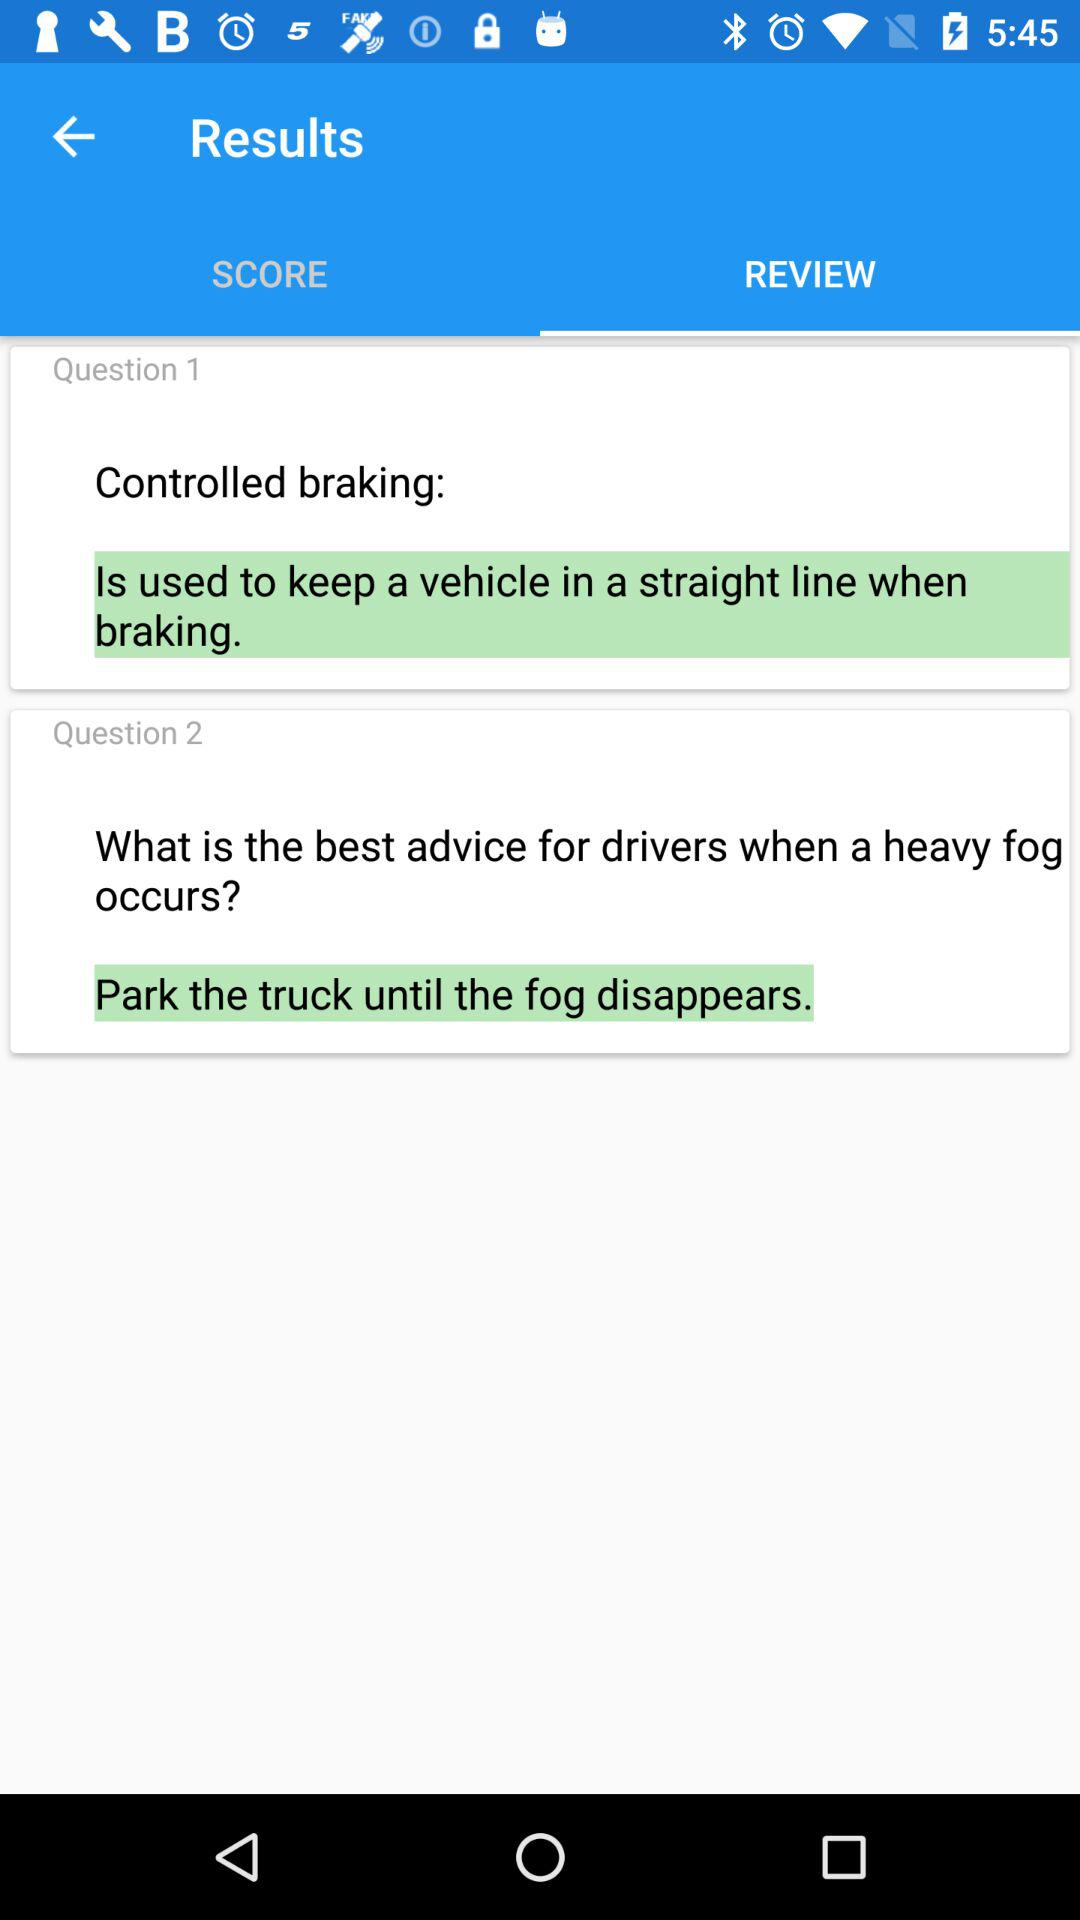Which tab is selected? The selected tab is "REVIEW". 